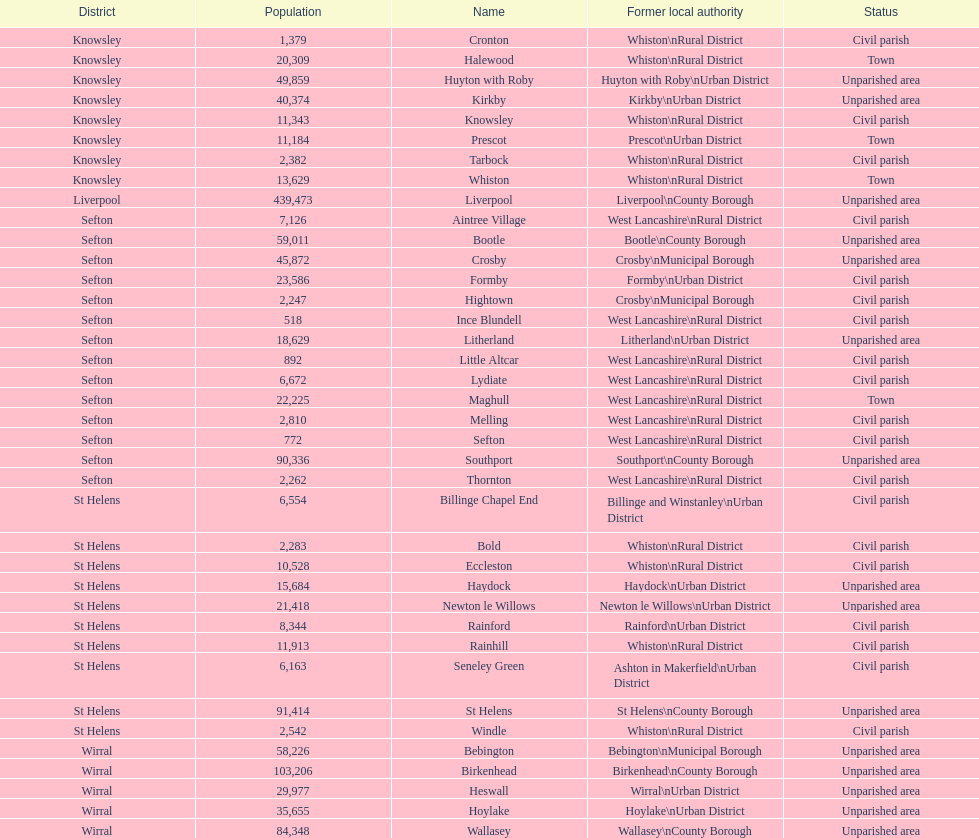How many people live in the bold civil parish? 2,283. 